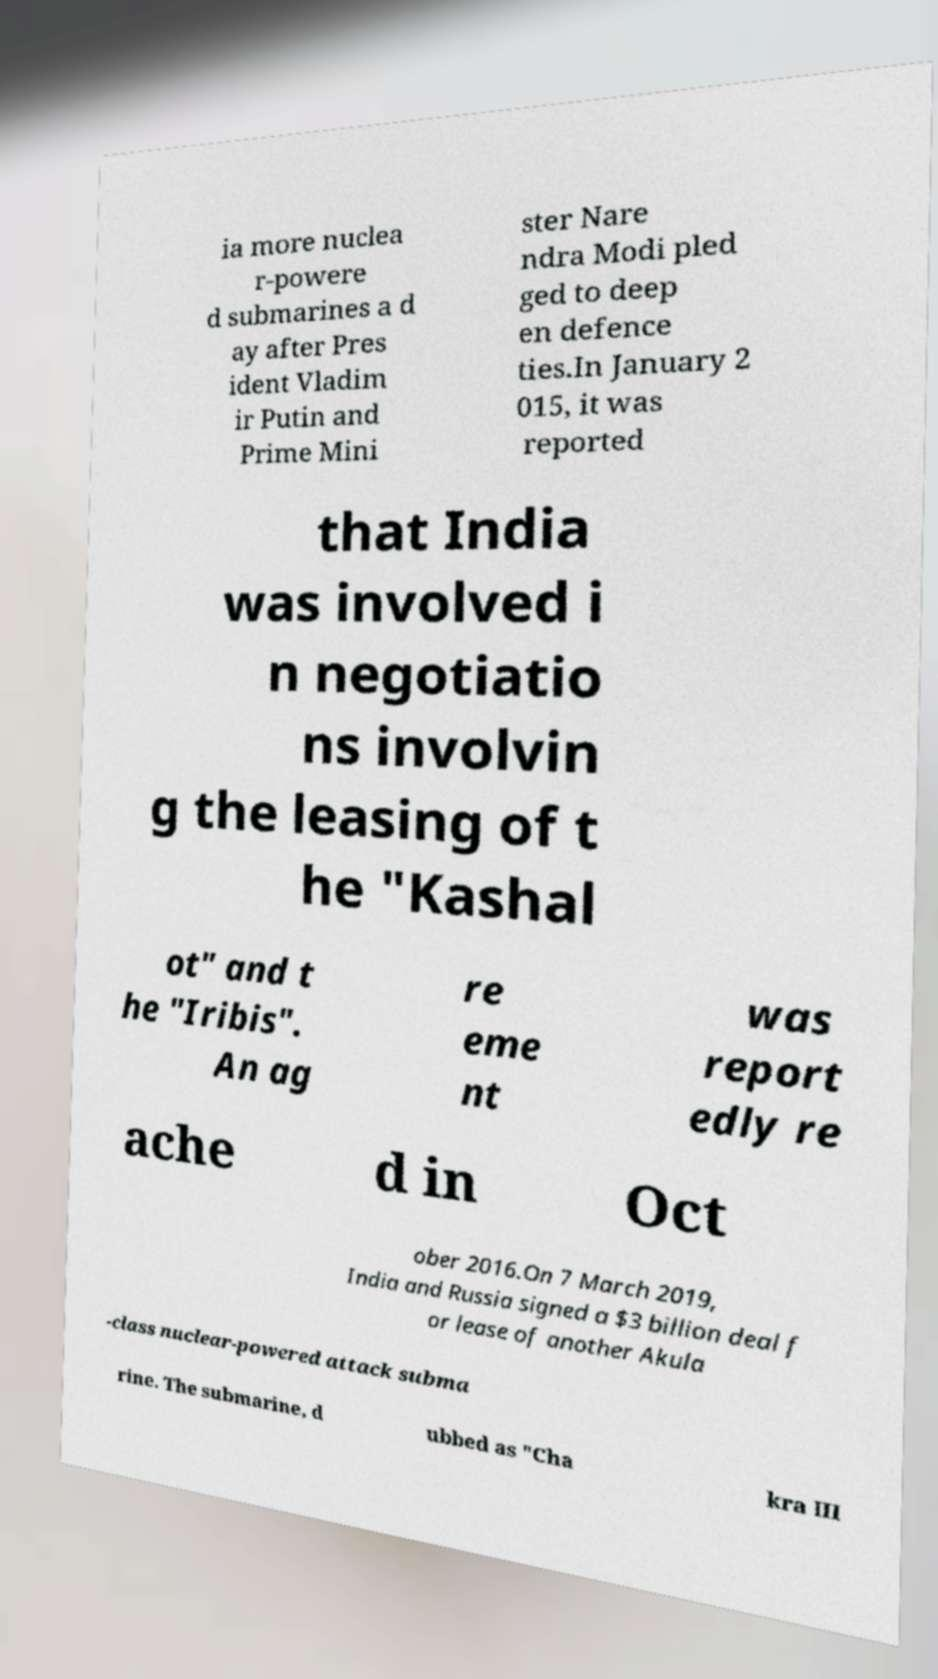There's text embedded in this image that I need extracted. Can you transcribe it verbatim? ia more nuclea r-powere d submarines a d ay after Pres ident Vladim ir Putin and Prime Mini ster Nare ndra Modi pled ged to deep en defence ties.In January 2 015, it was reported that India was involved i n negotiatio ns involvin g the leasing of t he "Kashal ot" and t he "Iribis". An ag re eme nt was report edly re ache d in Oct ober 2016.On 7 March 2019, India and Russia signed a $3 billion deal f or lease of another Akula -class nuclear-powered attack subma rine. The submarine, d ubbed as "Cha kra III 